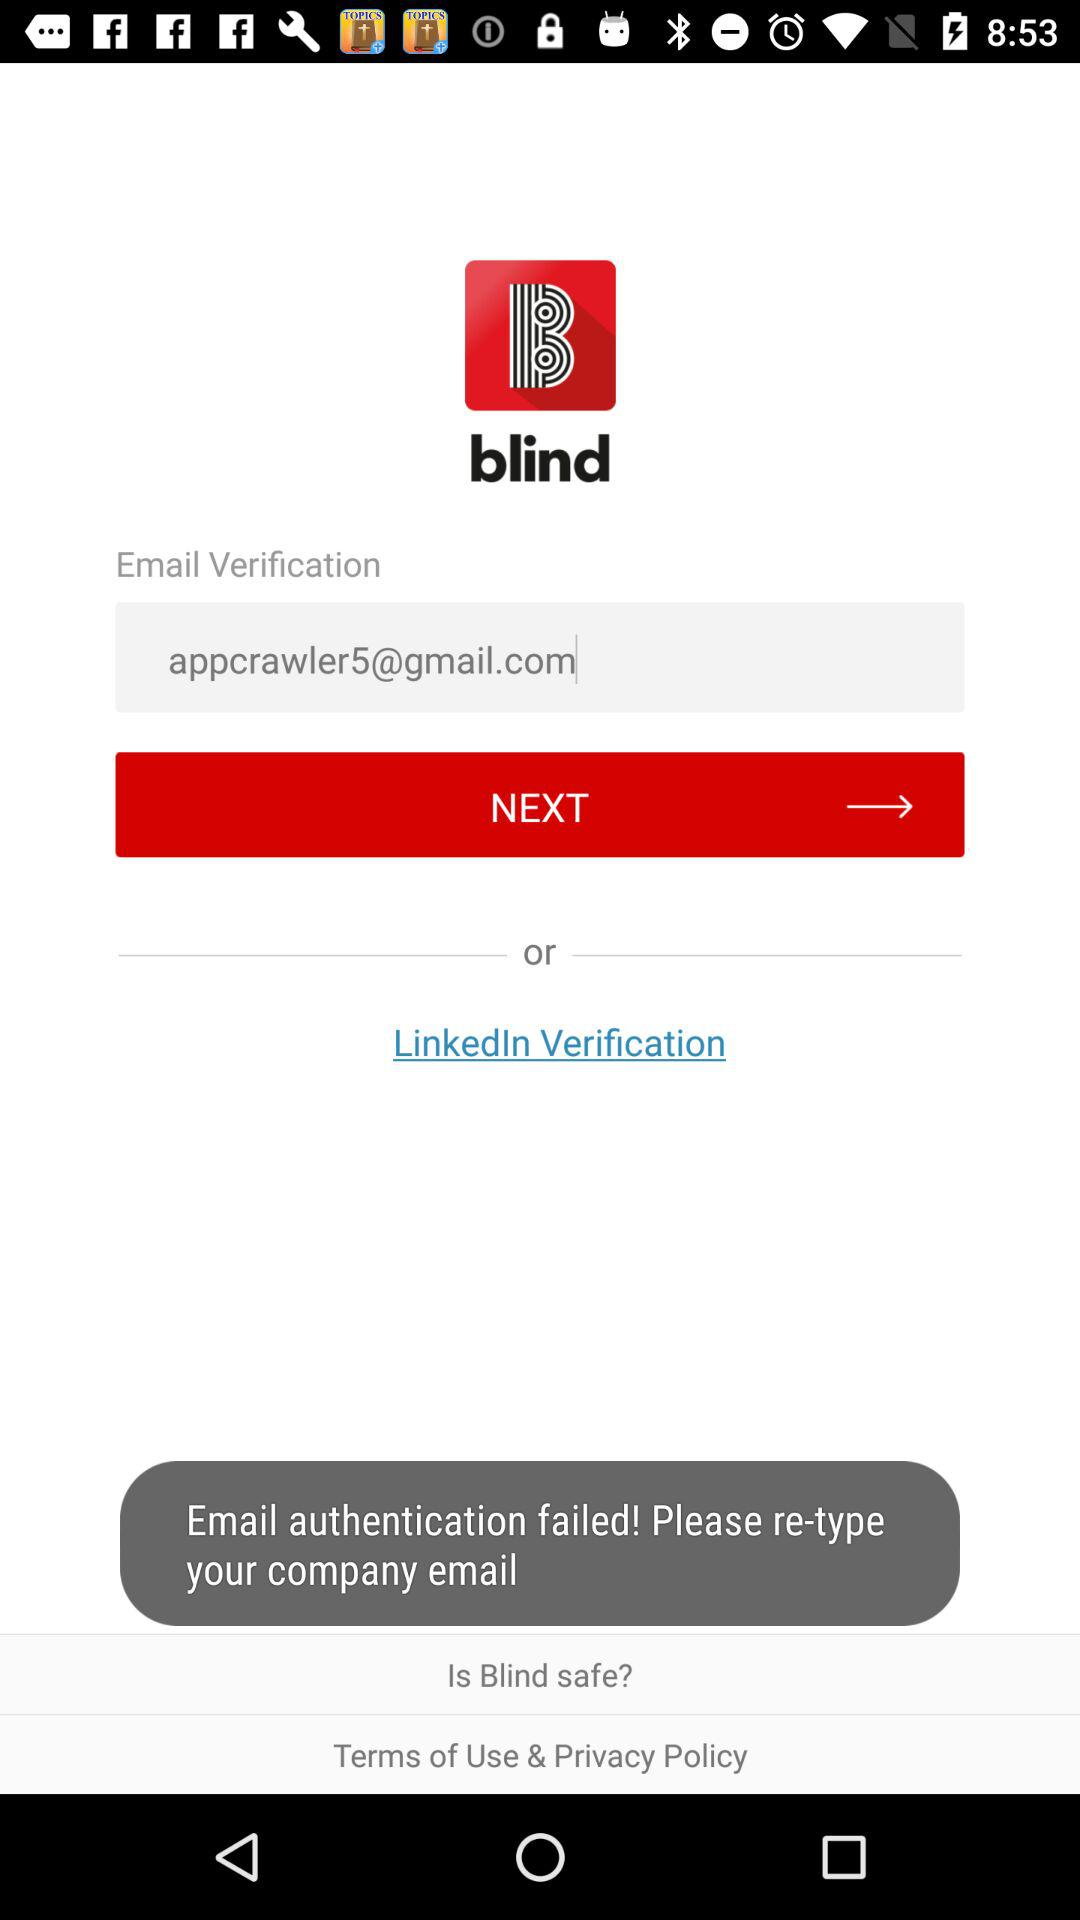What is the email address? The email address is appcrawler5@gmail.com. 